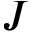Convert formula to latex. <formula><loc_0><loc_0><loc_500><loc_500>J</formula> 